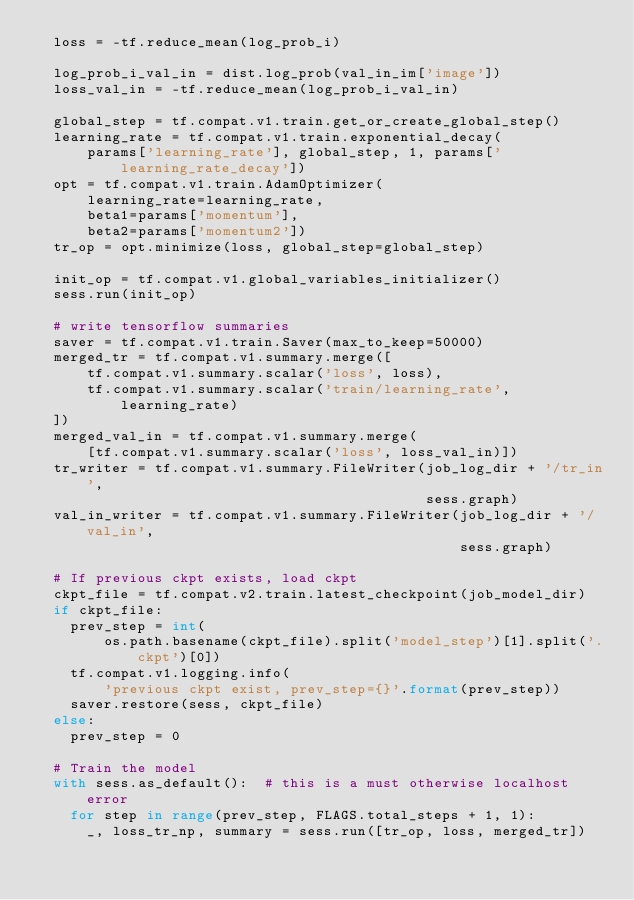Convert code to text. <code><loc_0><loc_0><loc_500><loc_500><_Python_>  loss = -tf.reduce_mean(log_prob_i)

  log_prob_i_val_in = dist.log_prob(val_in_im['image'])
  loss_val_in = -tf.reduce_mean(log_prob_i_val_in)

  global_step = tf.compat.v1.train.get_or_create_global_step()
  learning_rate = tf.compat.v1.train.exponential_decay(
      params['learning_rate'], global_step, 1, params['learning_rate_decay'])
  opt = tf.compat.v1.train.AdamOptimizer(
      learning_rate=learning_rate,
      beta1=params['momentum'],
      beta2=params['momentum2'])
  tr_op = opt.minimize(loss, global_step=global_step)

  init_op = tf.compat.v1.global_variables_initializer()
  sess.run(init_op)

  # write tensorflow summaries
  saver = tf.compat.v1.train.Saver(max_to_keep=50000)
  merged_tr = tf.compat.v1.summary.merge([
      tf.compat.v1.summary.scalar('loss', loss),
      tf.compat.v1.summary.scalar('train/learning_rate', learning_rate)
  ])
  merged_val_in = tf.compat.v1.summary.merge(
      [tf.compat.v1.summary.scalar('loss', loss_val_in)])
  tr_writer = tf.compat.v1.summary.FileWriter(job_log_dir + '/tr_in',
                                              sess.graph)
  val_in_writer = tf.compat.v1.summary.FileWriter(job_log_dir + '/val_in',
                                                  sess.graph)

  # If previous ckpt exists, load ckpt
  ckpt_file = tf.compat.v2.train.latest_checkpoint(job_model_dir)
  if ckpt_file:
    prev_step = int(
        os.path.basename(ckpt_file).split('model_step')[1].split('.ckpt')[0])
    tf.compat.v1.logging.info(
        'previous ckpt exist, prev_step={}'.format(prev_step))
    saver.restore(sess, ckpt_file)
  else:
    prev_step = 0

  # Train the model
  with sess.as_default():  # this is a must otherwise localhost error
    for step in range(prev_step, FLAGS.total_steps + 1, 1):
      _, loss_tr_np, summary = sess.run([tr_op, loss, merged_tr])</code> 